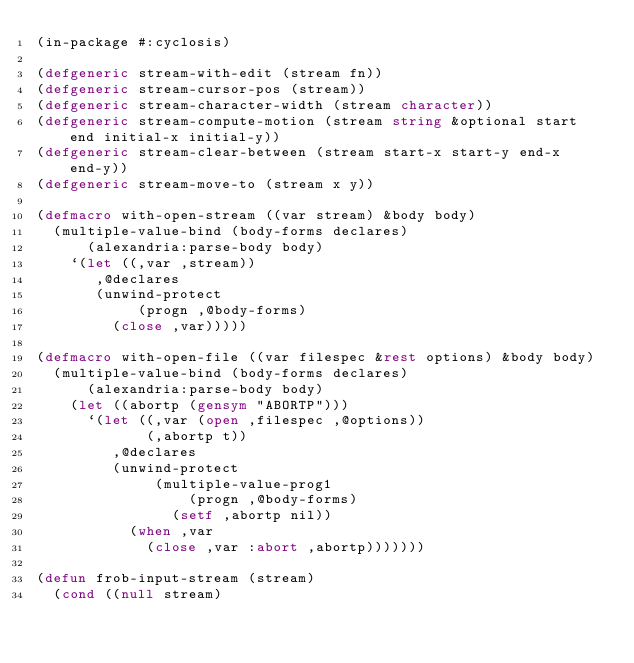Convert code to text. <code><loc_0><loc_0><loc_500><loc_500><_Lisp_>(in-package #:cyclosis)

(defgeneric stream-with-edit (stream fn))
(defgeneric stream-cursor-pos (stream))
(defgeneric stream-character-width (stream character))
(defgeneric stream-compute-motion (stream string &optional start end initial-x initial-y))
(defgeneric stream-clear-between (stream start-x start-y end-x end-y))
(defgeneric stream-move-to (stream x y))

(defmacro with-open-stream ((var stream) &body body)
  (multiple-value-bind (body-forms declares)
      (alexandria:parse-body body)
    `(let ((,var ,stream))
       ,@declares
       (unwind-protect
            (progn ,@body-forms)
         (close ,var)))))

(defmacro with-open-file ((var filespec &rest options) &body body)
  (multiple-value-bind (body-forms declares)
      (alexandria:parse-body body)
    (let ((abortp (gensym "ABORTP")))
      `(let ((,var (open ,filespec ,@options))
             (,abortp t))
         ,@declares
         (unwind-protect
              (multiple-value-prog1
                  (progn ,@body-forms)
                (setf ,abortp nil))
           (when ,var
             (close ,var :abort ,abortp)))))))

(defun frob-input-stream (stream)
  (cond ((null stream)</code> 